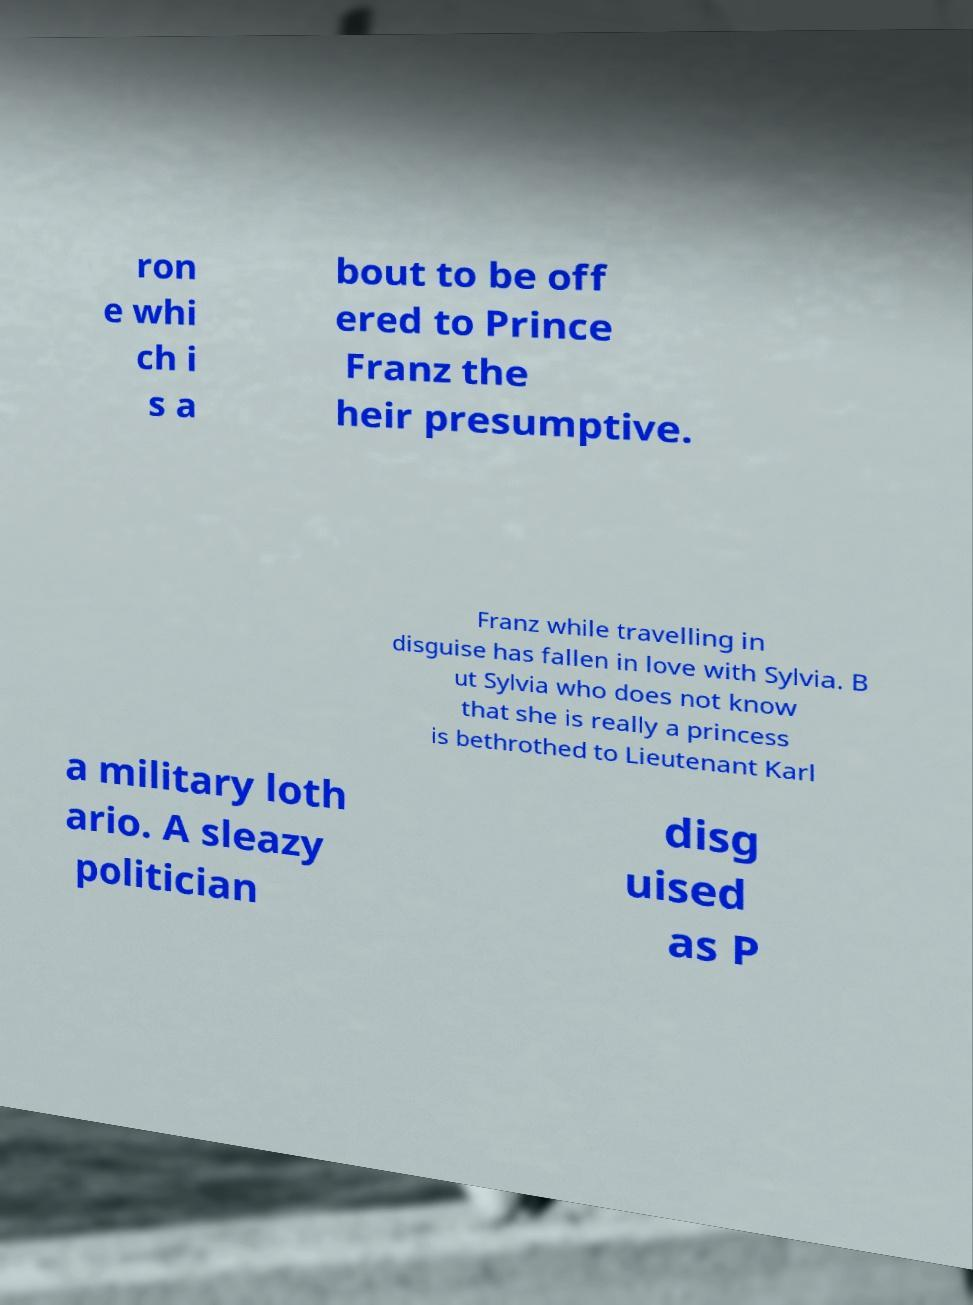Could you assist in decoding the text presented in this image and type it out clearly? ron e whi ch i s a bout to be off ered to Prince Franz the heir presumptive. Franz while travelling in disguise has fallen in love with Sylvia. B ut Sylvia who does not know that she is really a princess is bethrothed to Lieutenant Karl a military loth ario. A sleazy politician disg uised as P 